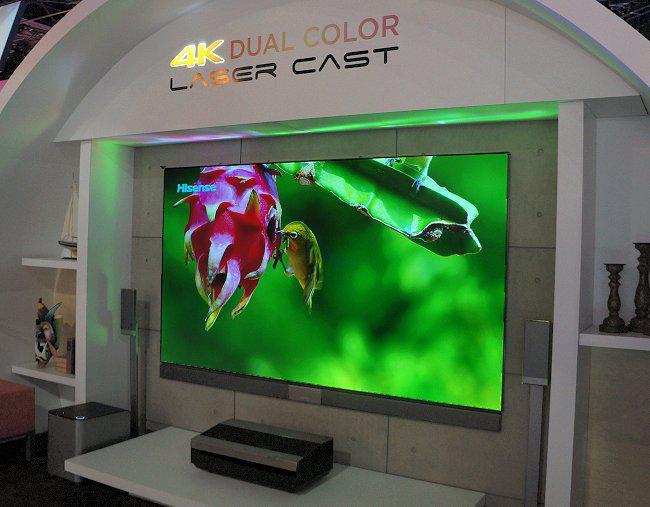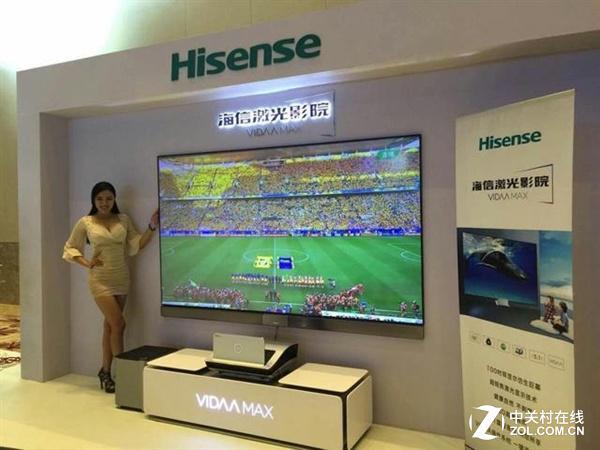The first image is the image on the left, the second image is the image on the right. Evaluate the accuracy of this statement regarding the images: "In at least one image you can see a green background and a hummingbird on the tv that is below gold lettering.". Is it true? Answer yes or no. Yes. The first image is the image on the left, the second image is the image on the right. Assess this claim about the two images: "One of the television sets is showing a pink flower on a green background.". Correct or not? Answer yes or no. Yes. 